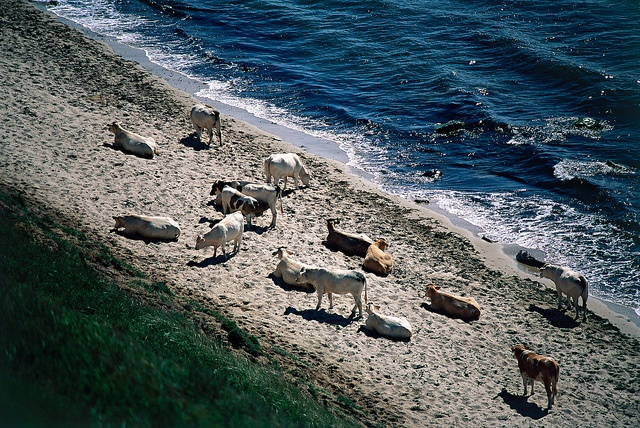Describe the objects in this image and their specific colors. I can see cow in purple, black, darkgray, gray, and lightgray tones, cow in purple, gray, black, and lightgray tones, cow in purple, gray, lightgray, black, and darkgray tones, cow in purple, black, gray, darkgray, and lightgray tones, and cow in purple, black, gray, white, and darkgray tones in this image. 